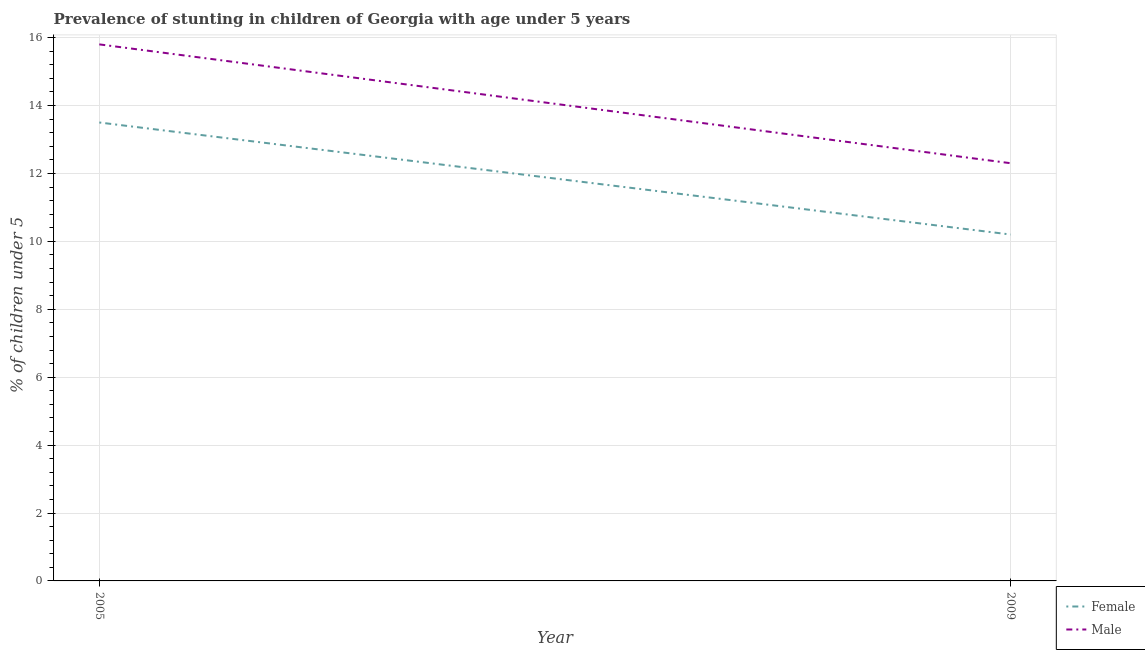How many different coloured lines are there?
Ensure brevity in your answer.  2. Does the line corresponding to percentage of stunted male children intersect with the line corresponding to percentage of stunted female children?
Ensure brevity in your answer.  No. Is the number of lines equal to the number of legend labels?
Ensure brevity in your answer.  Yes. Across all years, what is the maximum percentage of stunted female children?
Provide a short and direct response. 13.5. Across all years, what is the minimum percentage of stunted male children?
Provide a succinct answer. 12.3. In which year was the percentage of stunted female children maximum?
Your answer should be compact. 2005. What is the total percentage of stunted female children in the graph?
Provide a succinct answer. 23.7. What is the difference between the percentage of stunted male children in 2009 and the percentage of stunted female children in 2005?
Provide a succinct answer. -1.2. What is the average percentage of stunted female children per year?
Your answer should be very brief. 11.85. In the year 2005, what is the difference between the percentage of stunted female children and percentage of stunted male children?
Give a very brief answer. -2.3. What is the ratio of the percentage of stunted male children in 2005 to that in 2009?
Provide a succinct answer. 1.28. Is the percentage of stunted female children in 2005 less than that in 2009?
Offer a very short reply. No. Does the percentage of stunted male children monotonically increase over the years?
Give a very brief answer. No. How many years are there in the graph?
Offer a terse response. 2. Does the graph contain any zero values?
Your response must be concise. No. Does the graph contain grids?
Offer a terse response. Yes. How many legend labels are there?
Ensure brevity in your answer.  2. How are the legend labels stacked?
Offer a terse response. Vertical. What is the title of the graph?
Keep it short and to the point. Prevalence of stunting in children of Georgia with age under 5 years. What is the label or title of the X-axis?
Your answer should be very brief. Year. What is the label or title of the Y-axis?
Provide a succinct answer.  % of children under 5. What is the  % of children under 5 in Male in 2005?
Provide a succinct answer. 15.8. What is the  % of children under 5 in Female in 2009?
Your answer should be compact. 10.2. What is the  % of children under 5 in Male in 2009?
Give a very brief answer. 12.3. Across all years, what is the maximum  % of children under 5 in Male?
Offer a very short reply. 15.8. Across all years, what is the minimum  % of children under 5 of Female?
Make the answer very short. 10.2. Across all years, what is the minimum  % of children under 5 of Male?
Provide a short and direct response. 12.3. What is the total  % of children under 5 of Female in the graph?
Provide a short and direct response. 23.7. What is the total  % of children under 5 of Male in the graph?
Provide a short and direct response. 28.1. What is the average  % of children under 5 of Female per year?
Your response must be concise. 11.85. What is the average  % of children under 5 of Male per year?
Provide a succinct answer. 14.05. In the year 2009, what is the difference between the  % of children under 5 of Female and  % of children under 5 of Male?
Your answer should be very brief. -2.1. What is the ratio of the  % of children under 5 in Female in 2005 to that in 2009?
Ensure brevity in your answer.  1.32. What is the ratio of the  % of children under 5 in Male in 2005 to that in 2009?
Offer a very short reply. 1.28. What is the difference between the highest and the second highest  % of children under 5 in Female?
Keep it short and to the point. 3.3. What is the difference between the highest and the second highest  % of children under 5 of Male?
Ensure brevity in your answer.  3.5. What is the difference between the highest and the lowest  % of children under 5 of Female?
Offer a terse response. 3.3. 